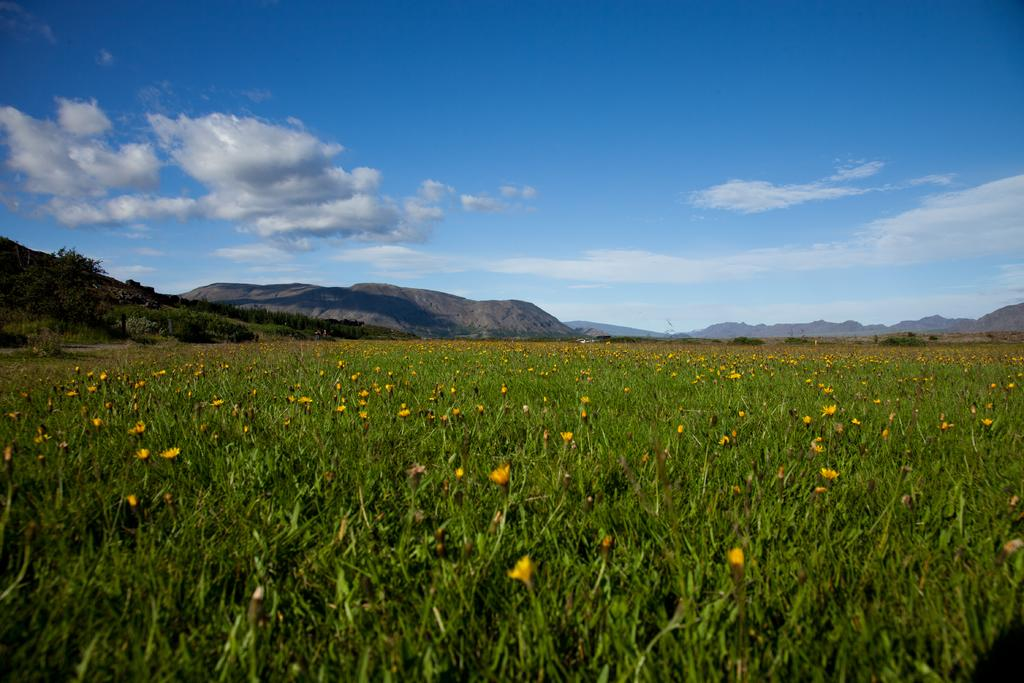What type of vegetation can be seen in the image? There are plants and flowers in the image. What can be seen in the background of the image? There are trees, mountains, and the sky visible in the background of the image. How many birds are flying over the harbor in the image? There is no harbor or birds present in the image. Is there a balloon visible in the image? There is no balloon present in the image. 